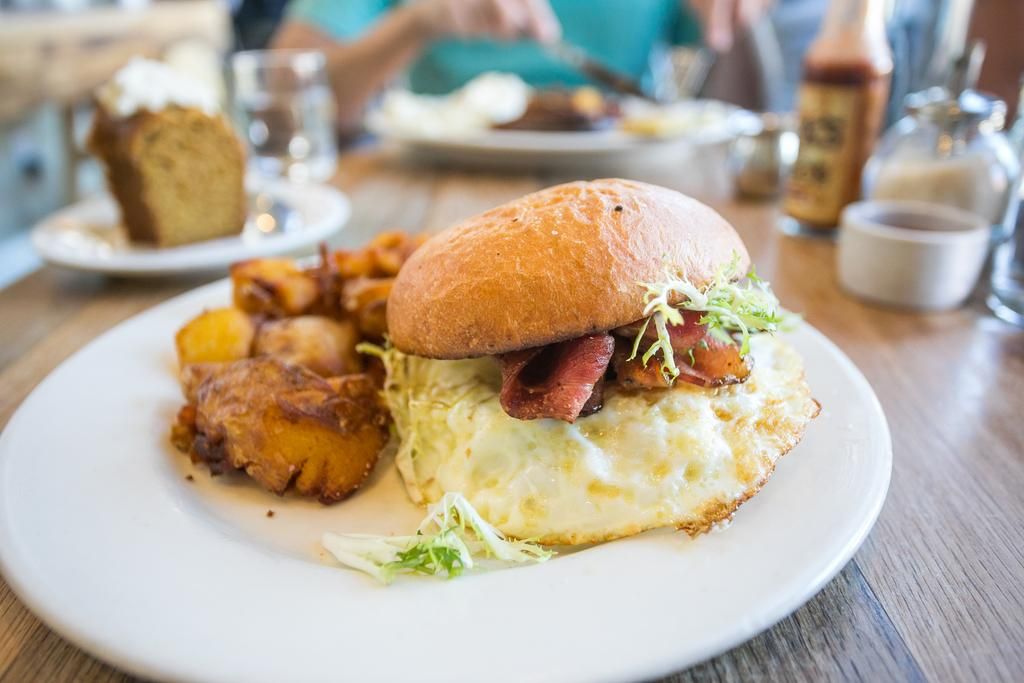What is present on the table in the image? There are food items or snacks on the table. Can you describe the food items or snacks in more detail? Unfortunately, the facts provided do not give any specific details about the food items or snacks. Are there any utensils or plates visible on the table? The facts provided do not mention any utensils or plates. Where is the daughter sitting in the image? There is no daughter present in the image; it only shows food items or snacks on the table. Can you see a nest in the image? There is no nest present in the image; it only shows food items or snacks on the table. 